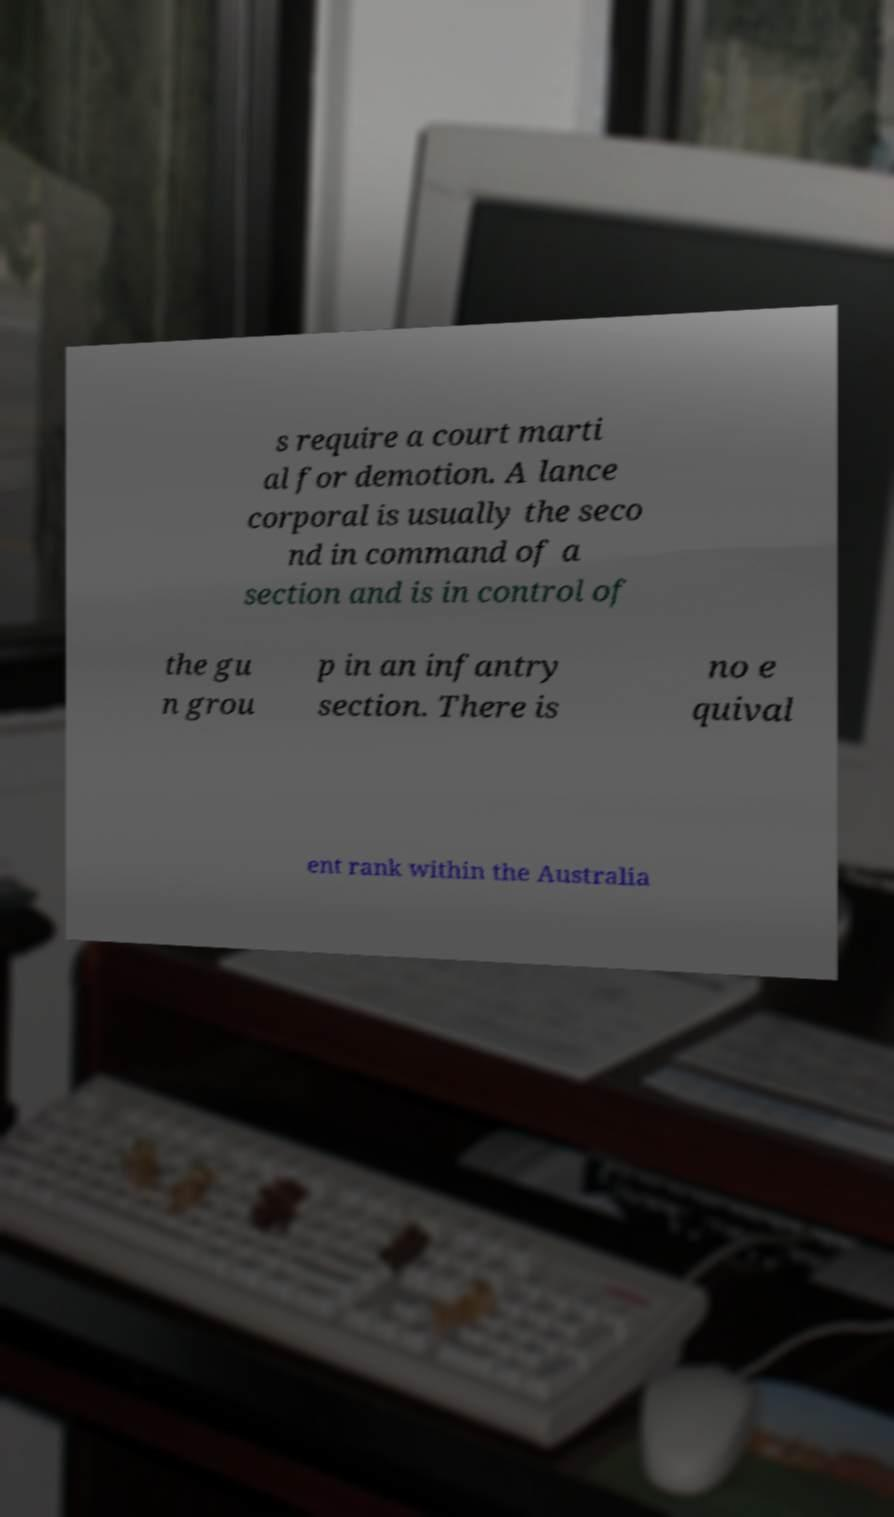Please read and relay the text visible in this image. What does it say? s require a court marti al for demotion. A lance corporal is usually the seco nd in command of a section and is in control of the gu n grou p in an infantry section. There is no e quival ent rank within the Australia 